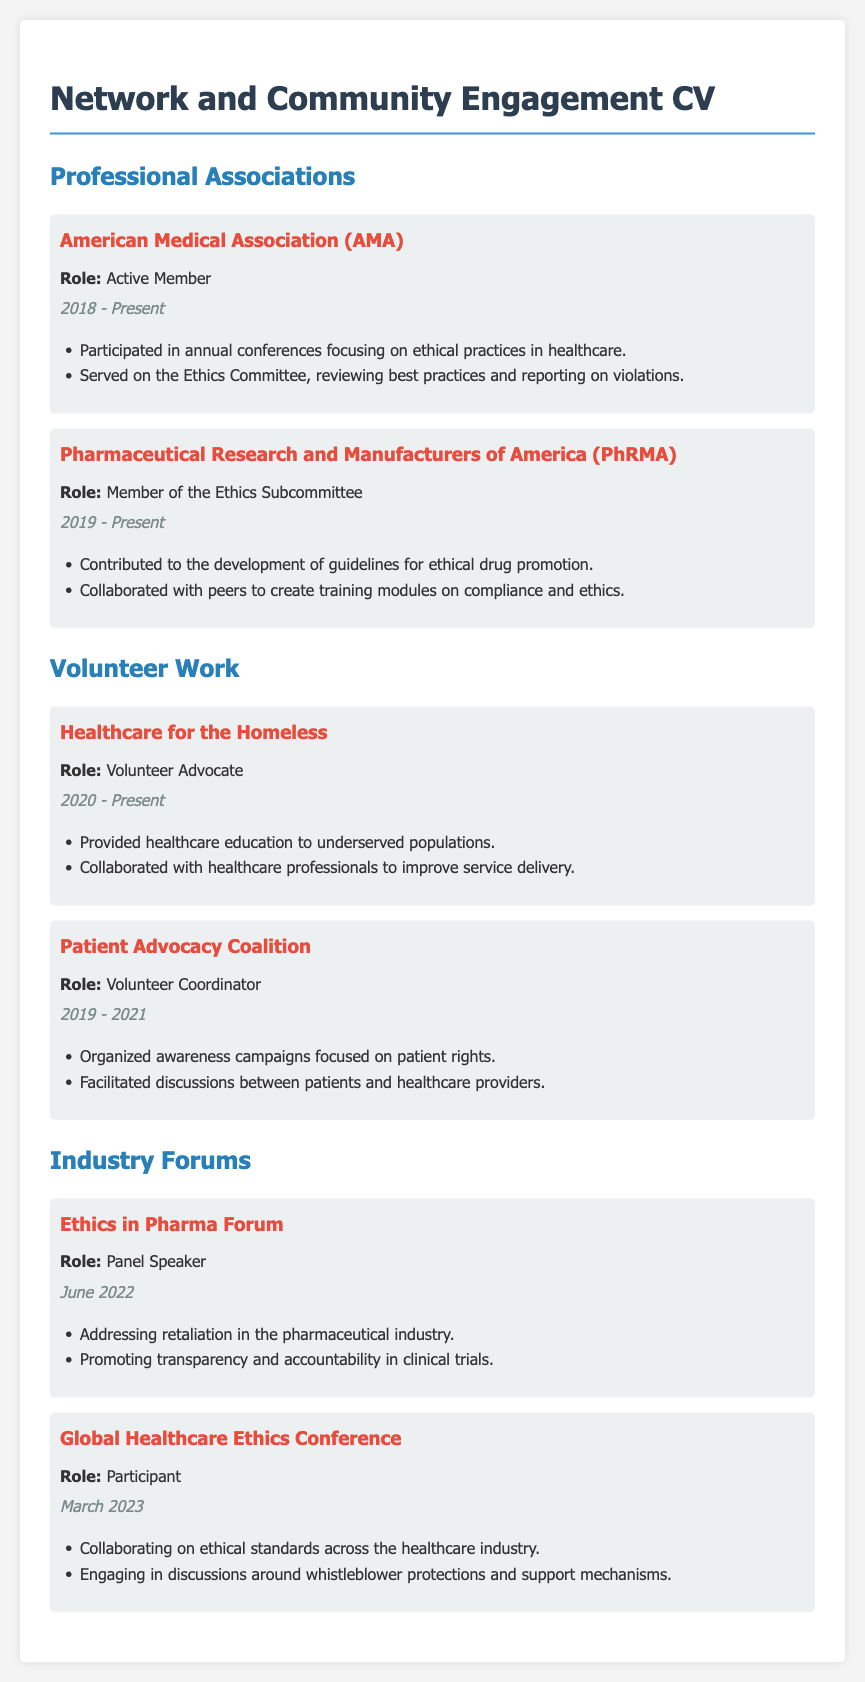what is the role in the American Medical Association? The document states the role as "Active Member."
Answer: Active Member what year did the volunteer work for Healthcare for the Homeless begin? The document indicates that the volunteer work started in 2020.
Answer: 2020 what is one of the contributions made at the Pharmaceutical Research and Manufacturers of America? The document lists "Contributed to the development of guidelines for ethical drug promotion." as a contribution.
Answer: Development of guidelines for ethical drug promotion who was the panel speaker at the Ethics in Pharma Forum? The document mentions the role of "Panel Speaker" but does not specify a name.
Answer: Panel Speaker what is the date of the Global Healthcare Ethics Conference? The document provides the date as March 2023.
Answer: March 2023 what role did the individual hold at the Patient Advocacy Coalition? The document states the role as "Volunteer Coordinator."
Answer: Volunteer Coordinator which committee did the individual serve on at the American Medical Association? The document refers to the "Ethics Committee."
Answer: Ethics Committee what type of campaigns did the Volunteer Coordinator organize? The document describes them as "awareness campaigns focused on patient rights."
Answer: Awareness campaigns focused on patient rights 